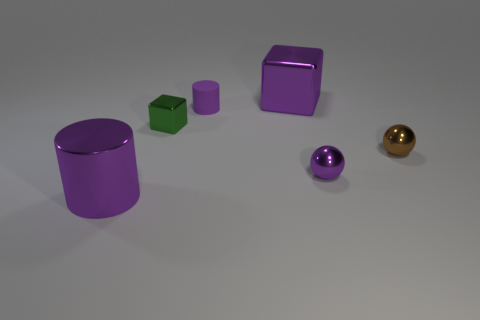How many other large cylinders are the same color as the large cylinder? There are no other large cylinders sharing the same color as the large cylinder visible in the image. 